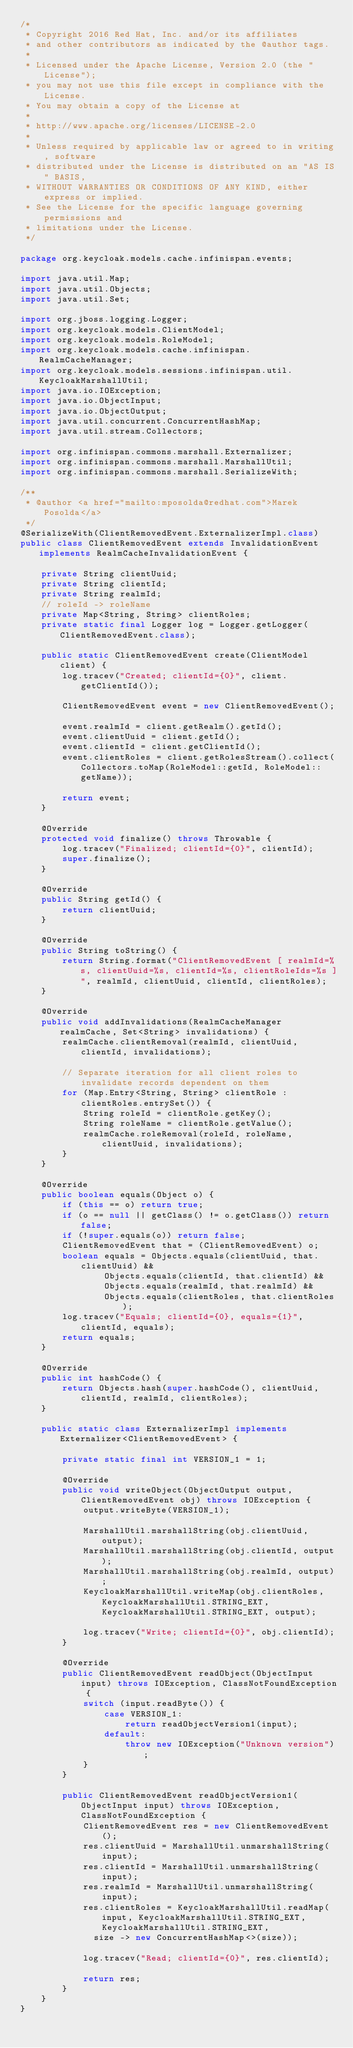Convert code to text. <code><loc_0><loc_0><loc_500><loc_500><_Java_>/*
 * Copyright 2016 Red Hat, Inc. and/or its affiliates
 * and other contributors as indicated by the @author tags.
 *
 * Licensed under the Apache License, Version 2.0 (the "License");
 * you may not use this file except in compliance with the License.
 * You may obtain a copy of the License at
 *
 * http://www.apache.org/licenses/LICENSE-2.0
 *
 * Unless required by applicable law or agreed to in writing, software
 * distributed under the License is distributed on an "AS IS" BASIS,
 * WITHOUT WARRANTIES OR CONDITIONS OF ANY KIND, either express or implied.
 * See the License for the specific language governing permissions and
 * limitations under the License.
 */

package org.keycloak.models.cache.infinispan.events;

import java.util.Map;
import java.util.Objects;
import java.util.Set;

import org.jboss.logging.Logger;
import org.keycloak.models.ClientModel;
import org.keycloak.models.RoleModel;
import org.keycloak.models.cache.infinispan.RealmCacheManager;
import org.keycloak.models.sessions.infinispan.util.KeycloakMarshallUtil;
import java.io.IOException;
import java.io.ObjectInput;
import java.io.ObjectOutput;
import java.util.concurrent.ConcurrentHashMap;
import java.util.stream.Collectors;

import org.infinispan.commons.marshall.Externalizer;
import org.infinispan.commons.marshall.MarshallUtil;
import org.infinispan.commons.marshall.SerializeWith;

/**
 * @author <a href="mailto:mposolda@redhat.com">Marek Posolda</a>
 */
@SerializeWith(ClientRemovedEvent.ExternalizerImpl.class)
public class ClientRemovedEvent extends InvalidationEvent implements RealmCacheInvalidationEvent {

    private String clientUuid;
    private String clientId;
    private String realmId;
    // roleId -> roleName
    private Map<String, String> clientRoles;
    private static final Logger log = Logger.getLogger(ClientRemovedEvent.class);

    public static ClientRemovedEvent create(ClientModel client) {
        log.tracev("Created; clientId={0}", client.getClientId());

        ClientRemovedEvent event = new ClientRemovedEvent();

        event.realmId = client.getRealm().getId();
        event.clientUuid = client.getId();
        event.clientId = client.getClientId();
        event.clientRoles = client.getRolesStream().collect(Collectors.toMap(RoleModel::getId, RoleModel::getName));

        return event;
    }

    @Override
    protected void finalize() throws Throwable {
        log.tracev("Finalized; clientId={0}", clientId);
        super.finalize();
    }

    @Override
    public String getId() {
        return clientUuid;
    }

    @Override
    public String toString() {
        return String.format("ClientRemovedEvent [ realmId=%s, clientUuid=%s, clientId=%s, clientRoleIds=%s ]", realmId, clientUuid, clientId, clientRoles);
    }

    @Override
    public void addInvalidations(RealmCacheManager realmCache, Set<String> invalidations) {
        realmCache.clientRemoval(realmId, clientUuid, clientId, invalidations);

        // Separate iteration for all client roles to invalidate records dependent on them
        for (Map.Entry<String, String> clientRole : clientRoles.entrySet()) {
            String roleId = clientRole.getKey();
            String roleName = clientRole.getValue();
            realmCache.roleRemoval(roleId, roleName, clientUuid, invalidations);
        }
    }

    @Override
    public boolean equals(Object o) {
        if (this == o) return true;
        if (o == null || getClass() != o.getClass()) return false;
        if (!super.equals(o)) return false;
        ClientRemovedEvent that = (ClientRemovedEvent) o;
        boolean equals = Objects.equals(clientUuid, that.clientUuid) &&
                Objects.equals(clientId, that.clientId) &&
                Objects.equals(realmId, that.realmId) &&
                Objects.equals(clientRoles, that.clientRoles);
        log.tracev("Equals; clientId={0}, equals={1}", clientId, equals);
        return equals;
    }

    @Override
    public int hashCode() {
        return Objects.hash(super.hashCode(), clientUuid, clientId, realmId, clientRoles);
    }

    public static class ExternalizerImpl implements Externalizer<ClientRemovedEvent> {

        private static final int VERSION_1 = 1;

        @Override
        public void writeObject(ObjectOutput output, ClientRemovedEvent obj) throws IOException {
            output.writeByte(VERSION_1);

            MarshallUtil.marshallString(obj.clientUuid, output);
            MarshallUtil.marshallString(obj.clientId, output);
            MarshallUtil.marshallString(obj.realmId, output);
            KeycloakMarshallUtil.writeMap(obj.clientRoles, KeycloakMarshallUtil.STRING_EXT, KeycloakMarshallUtil.STRING_EXT, output);

            log.tracev("Write; clientId={0}", obj.clientId);
        }

        @Override
        public ClientRemovedEvent readObject(ObjectInput input) throws IOException, ClassNotFoundException {
            switch (input.readByte()) {
                case VERSION_1:
                    return readObjectVersion1(input);
                default:
                    throw new IOException("Unknown version");
            }
        }

        public ClientRemovedEvent readObjectVersion1(ObjectInput input) throws IOException, ClassNotFoundException {
            ClientRemovedEvent res = new ClientRemovedEvent();
            res.clientUuid = MarshallUtil.unmarshallString(input);
            res.clientId = MarshallUtil.unmarshallString(input);
            res.realmId = MarshallUtil.unmarshallString(input);
            res.clientRoles = KeycloakMarshallUtil.readMap(input, KeycloakMarshallUtil.STRING_EXT, KeycloakMarshallUtil.STRING_EXT,
              size -> new ConcurrentHashMap<>(size));

            log.tracev("Read; clientId={0}", res.clientId);

            return res;
        }
    }
}
</code> 